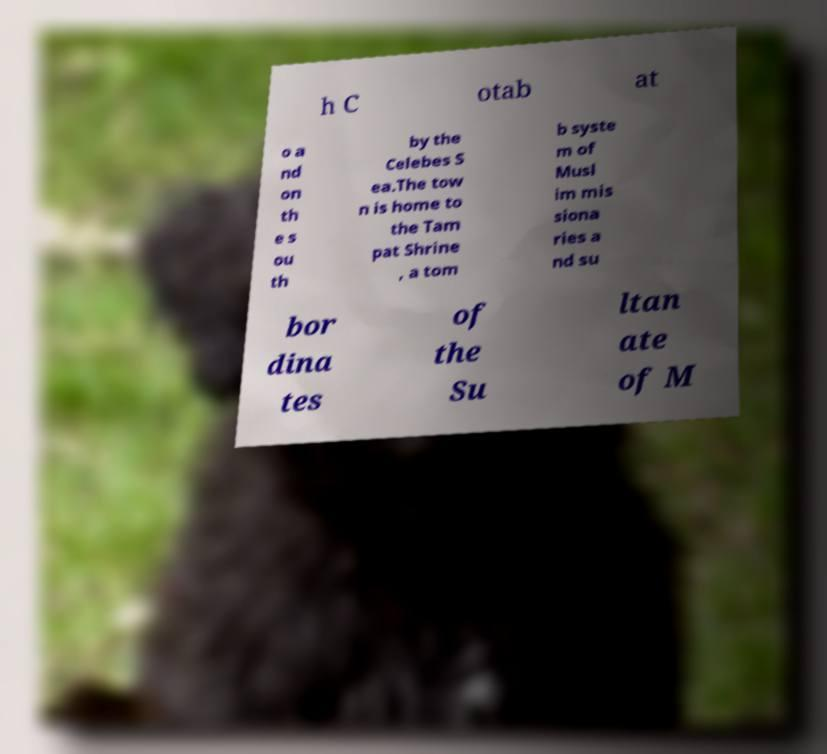What messages or text are displayed in this image? I need them in a readable, typed format. h C otab at o a nd on th e s ou th by the Celebes S ea.The tow n is home to the Tam pat Shrine , a tom b syste m of Musl im mis siona ries a nd su bor dina tes of the Su ltan ate of M 